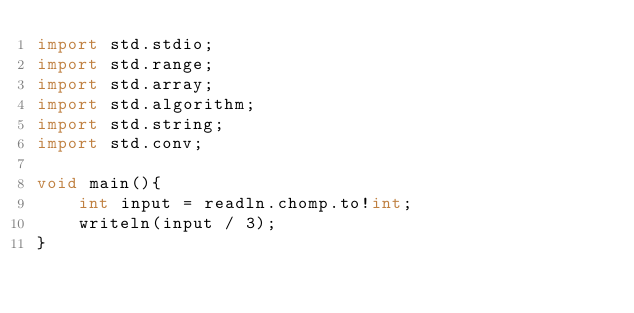<code> <loc_0><loc_0><loc_500><loc_500><_D_>import std.stdio;
import std.range;
import std.array;
import std.algorithm;
import std.string;
import std.conv;

void main(){
    int input = readln.chomp.to!int;
    writeln(input / 3);
}</code> 